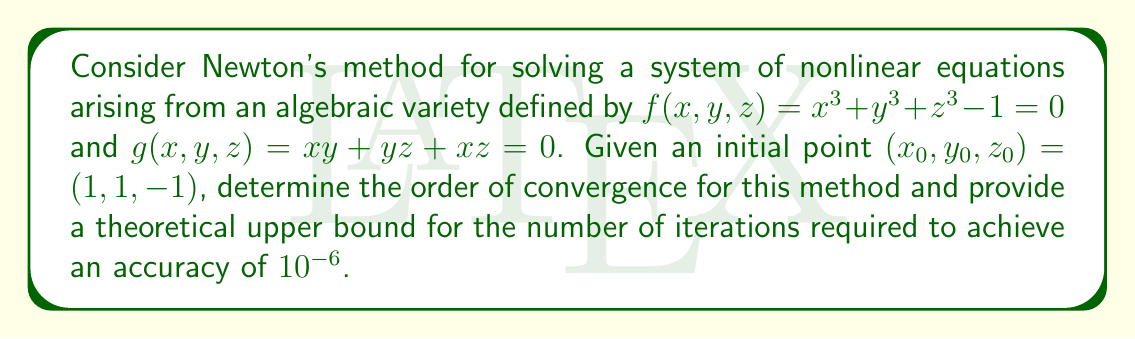Could you help me with this problem? To analyze the convergence of Newton's method for this system, we'll follow these steps:

1) First, recall that Newton's method for a system of nonlinear equations is given by:

   $$\mathbf{x}_{k+1} = \mathbf{x}_k - J(\mathbf{x}_k)^{-1}F(\mathbf{x}_k)$$

   where $J$ is the Jacobian matrix and $F$ is the vector of functions.

2) For our system, $F(\mathbf{x}) = \begin{pmatrix} f(x,y,z) \\ g(x,y,z) \end{pmatrix}$ and the Jacobian is:

   $$J = \begin{bmatrix} 
   3x^2 & 3y^2 & 3z^2 \\
   y+z & x+z & x+y
   \end{bmatrix}$$

3) Newton's method for systems of nonlinear equations has quadratic convergence in the neighborhood of a simple root, meaning the order of convergence is 2.

4) To estimate the number of iterations, we can use the following inequality for quadratic convergence:

   $$\|\mathbf{x}_{k+1} - \mathbf{x}^*\| \leq C\|\mathbf{x}_k - \mathbf{x}^*\|^2$$

   where $C$ is a constant and $\mathbf{x}^*$ is the true solution.

5) Let $\epsilon_k = \|\mathbf{x}_k - \mathbf{x}^*\|$. Then we have:

   $$\epsilon_{k+1} \leq C\epsilon_k^2$$

6) Taking logarithms:

   $$\log \epsilon_{k+1} \leq \log C + 2\log \epsilon_k$$

7) After $n$ iterations:

   $$\log \epsilon_n \leq (2^n)\log \epsilon_0 + (2^n - 1)\log C$$

8) We want $\epsilon_n \leq 10^{-6}$, so:

   $$-6 \geq 2^n \log \epsilon_0 + (2^n - 1)\log C$$

9) Solving this inequality for $n$ gives us an upper bound on the number of iterations. However, without knowing the exact values of $\epsilon_0$ and $C$, we can't give a precise number.

10) Theoretically, if we assume $\epsilon_0 \approx 1$ (since our initial guess is not too far from a potential solution) and $C \approx 1$, we get:

    $$n \geq \log_2(\log_2(10^6)) \approx 4.22$$

Therefore, the theoretical upper bound for the number of iterations is 5.
Answer: Order of convergence: 2; Upper bound on iterations: 5 